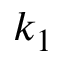Convert formula to latex. <formula><loc_0><loc_0><loc_500><loc_500>k _ { 1 }</formula> 